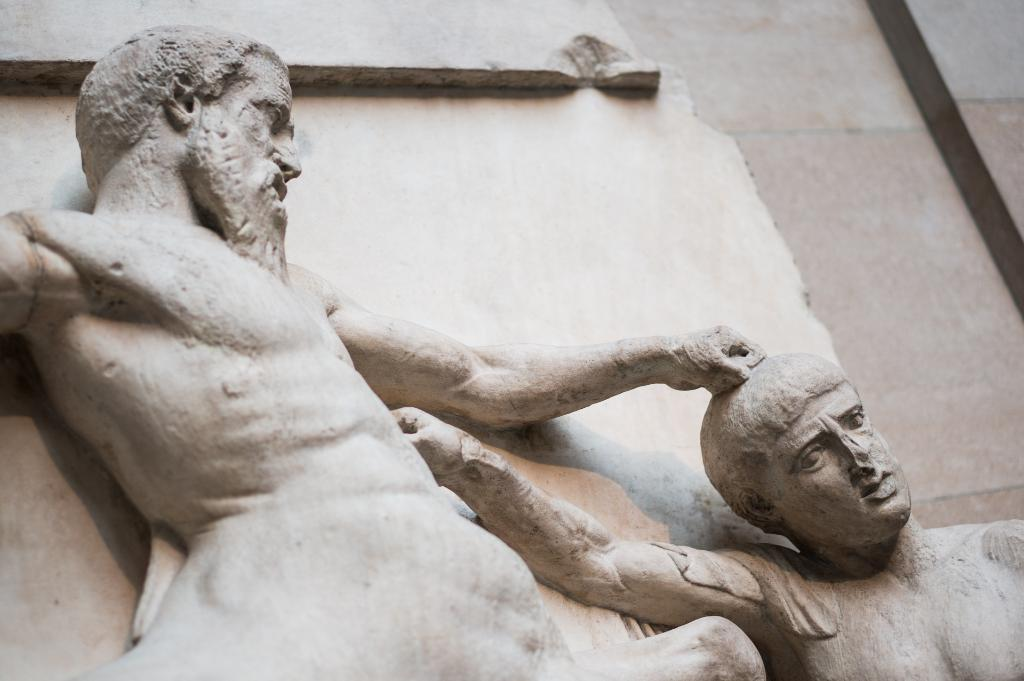What objects are present in the image? There are statues in the image. What can be seen in the background of the image? There is a wall visible in the background of the image. What type of jeans are the statues wearing in the image? The statues in the image are not wearing jeans, as they are not human figures. Can you see any scissors in the image? There are no scissors present in the image. 